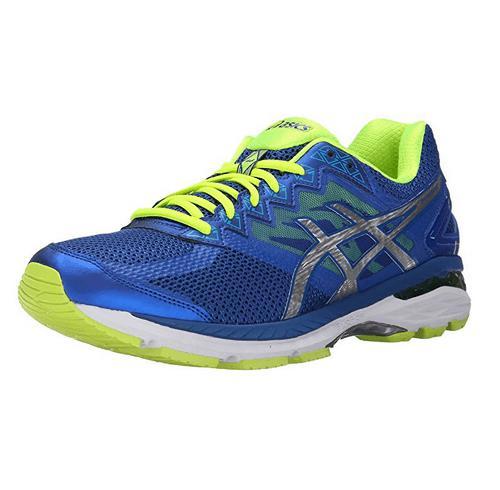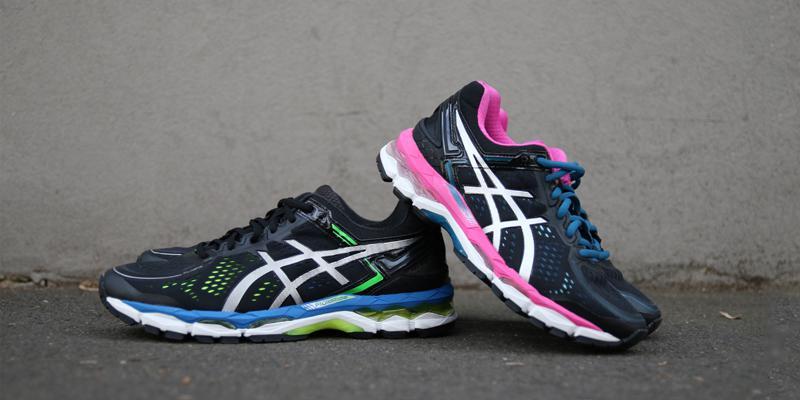The first image is the image on the left, the second image is the image on the right. Given the left and right images, does the statement "The left image is a blue shoe on a white background." hold true? Answer yes or no. Yes. 